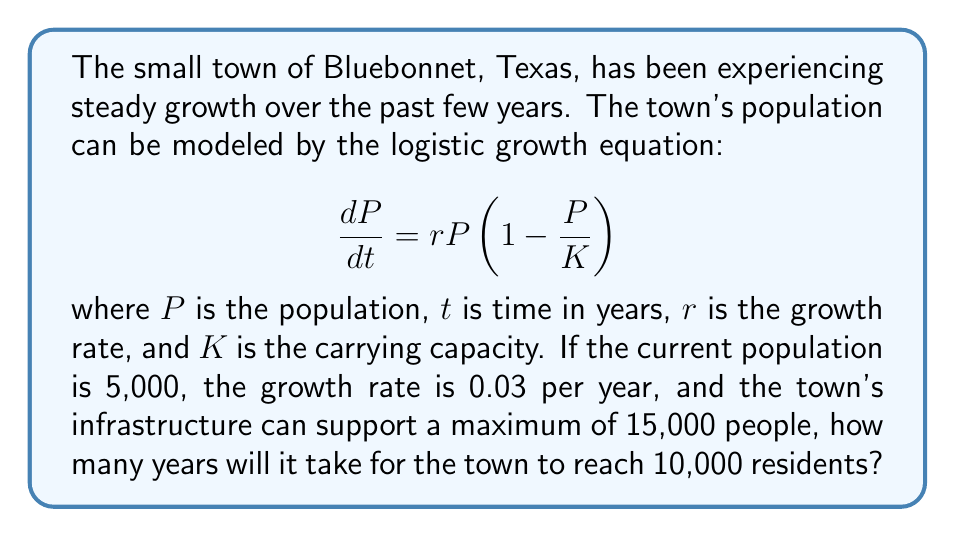What is the answer to this math problem? Let's approach this step-by-step:

1) The logistic growth equation has the following solution:

   $$P(t) = \frac{K}{1 + (\frac{K}{P_0} - 1)e^{-rt}}$$

   where $P_0$ is the initial population.

2) We're given:
   $P_0 = 5,000$
   $K = 15,000$
   $r = 0.03$
   We want to find $t$ when $P(t) = 10,000$

3) Let's substitute these values into the equation:

   $$10,000 = \frac{15,000}{1 + (\frac{15,000}{5,000} - 1)e^{-0.03t}}$$

4) Simplify:

   $$10,000 = \frac{15,000}{1 + 2e^{-0.03t}}$$

5) Multiply both sides by $(1 + 2e^{-0.03t})$:

   $$10,000(1 + 2e^{-0.03t}) = 15,000$$

6) Distribute:

   $$10,000 + 20,000e^{-0.03t} = 15,000$$

7) Subtract 10,000 from both sides:

   $$20,000e^{-0.03t} = 5,000$$

8) Divide both sides by 20,000:

   $$e^{-0.03t} = 0.25$$

9) Take the natural log of both sides:

   $$-0.03t = \ln(0.25)$$

10) Solve for $t$:

    $$t = -\frac{\ln(0.25)}{0.03} \approx 46.21$$

Therefore, it will take approximately 46.21 years for Bluebonnet to reach 10,000 residents.
Answer: 46.21 years 